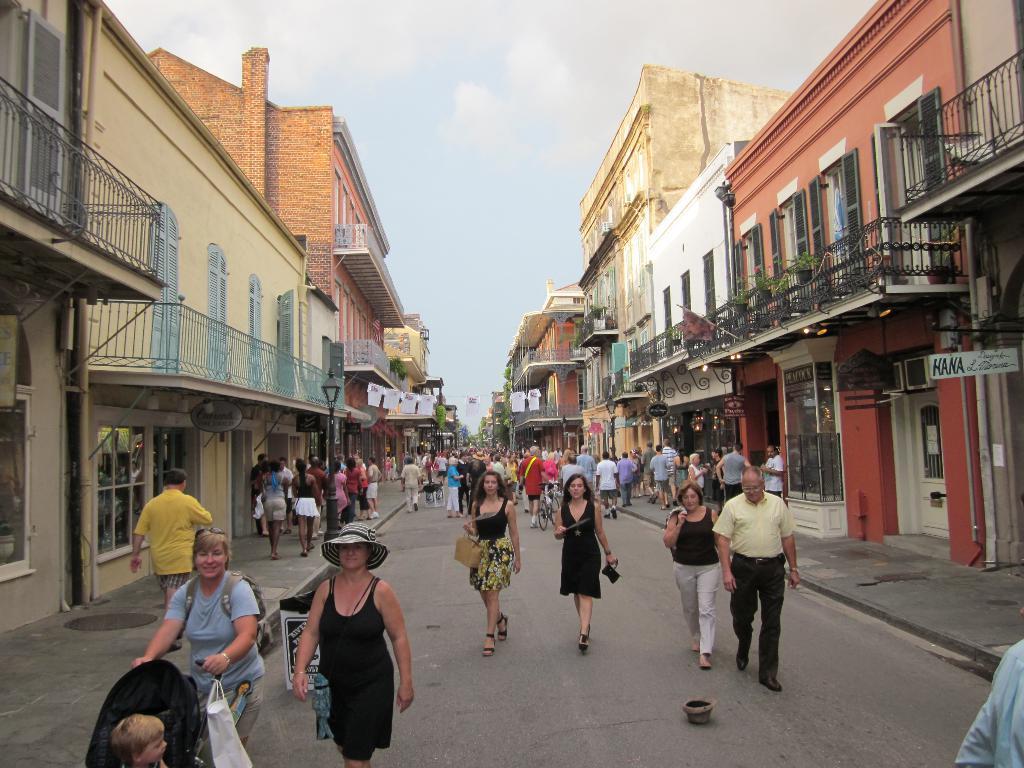How would you summarize this image in a sentence or two? In the center of the image we can see some people are walking on the road and some of them are carrying the bags and some of them are holding the bicycles. At the bottom of the image we can a lady is wearing a hat and another lady is holding a baby trolley. In the background of the image we can see the buildings, balconies, windows, boards, pots, plants. At the top of the image we can see the sky. 